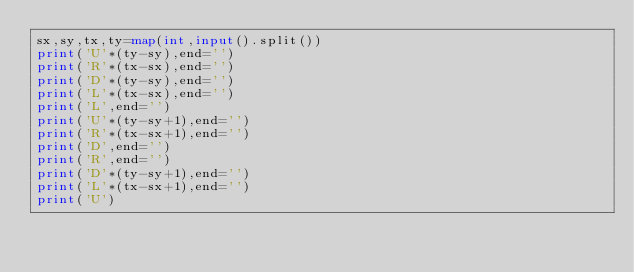Convert code to text. <code><loc_0><loc_0><loc_500><loc_500><_Python_>sx,sy,tx,ty=map(int,input().split())
print('U'*(ty-sy),end='')
print('R'*(tx-sx),end='')
print('D'*(ty-sy),end='')
print('L'*(tx-sx),end='')
print('L',end='')
print('U'*(ty-sy+1),end='')
print('R'*(tx-sx+1),end='')
print('D',end='')
print('R',end='')
print('D'*(ty-sy+1),end='')
print('L'*(tx-sx+1),end='')
print('U')


</code> 